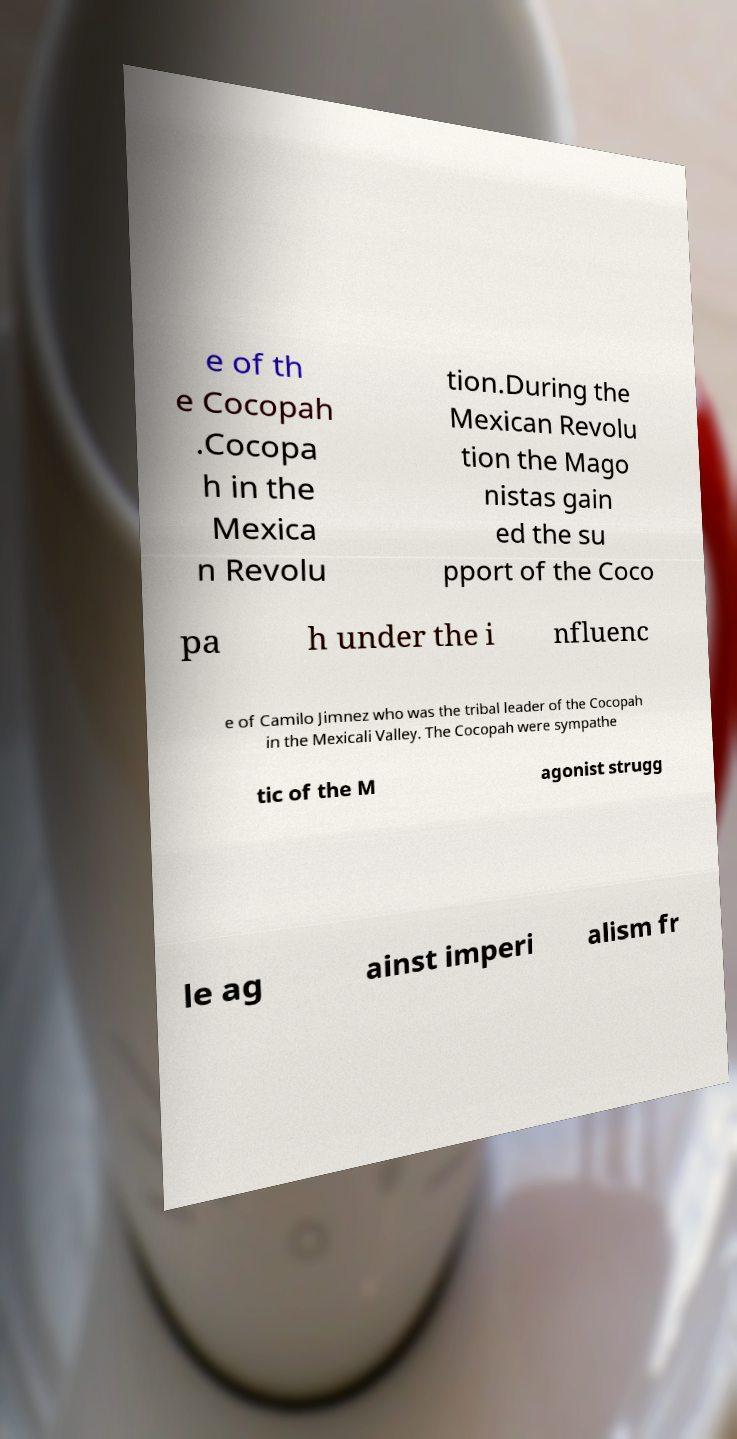Can you accurately transcribe the text from the provided image for me? e of th e Cocopah .Cocopa h in the Mexica n Revolu tion.During the Mexican Revolu tion the Mago nistas gain ed the su pport of the Coco pa h under the i nfluenc e of Camilo Jimnez who was the tribal leader of the Cocopah in the Mexicali Valley. The Cocopah were sympathe tic of the M agonist strugg le ag ainst imperi alism fr 